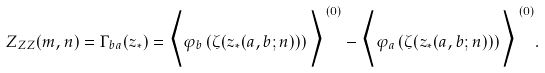Convert formula to latex. <formula><loc_0><loc_0><loc_500><loc_500>Z _ { Z Z } ( m , n ) = \Gamma _ { b a } ( z _ { * } ) = \Big < \varphi _ { b } \left ( \zeta ( z _ { * } ( a , b ; n ) ) \right ) \Big > ^ { \, ( 0 ) } - \Big < \varphi _ { a } \left ( \zeta ( z _ { * } ( a , b ; n ) ) \right ) \Big > ^ { \, ( 0 ) } .</formula> 